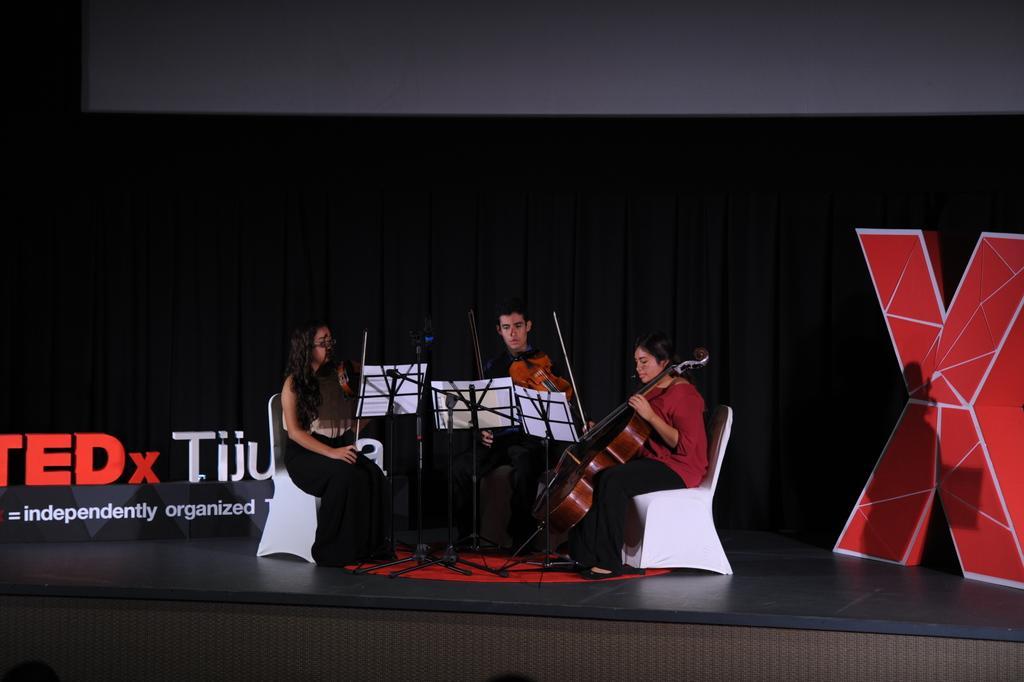How would you summarize this image in a sentence or two? There are three people sitting in a white chair and playing violin and there is a stand in front of them which has a white paper on it and the background is black in color with something written on the left corner. 